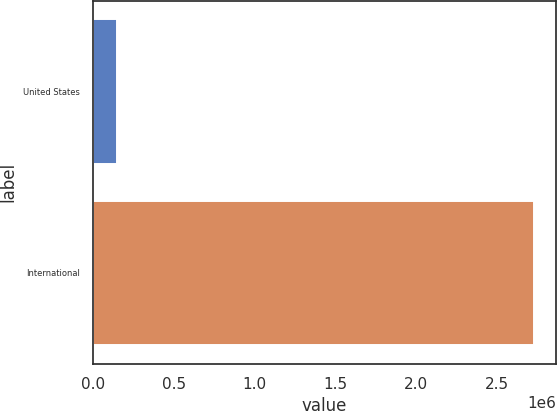Convert chart. <chart><loc_0><loc_0><loc_500><loc_500><bar_chart><fcel>United States<fcel>International<nl><fcel>148773<fcel>2.73038e+06<nl></chart> 